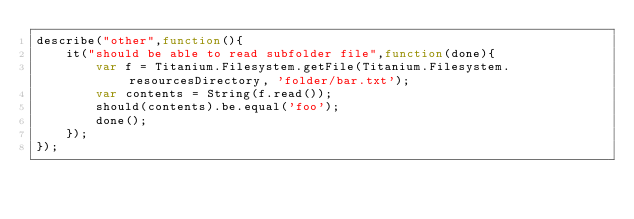<code> <loc_0><loc_0><loc_500><loc_500><_JavaScript_>describe("other",function(){
	it("should be able to read subfolder file",function(done){
        var f = Titanium.Filesystem.getFile(Titanium.Filesystem.resourcesDirectory, 'folder/bar.txt');
        var contents = String(f.read());
        should(contents).be.equal('foo');
        done();
	});
});</code> 